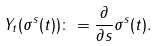<formula> <loc_0><loc_0><loc_500><loc_500>Y _ { t } ( \sigma ^ { s } ( t ) ) \colon = \frac { \partial } { \partial s } \sigma ^ { s } ( t ) .</formula> 